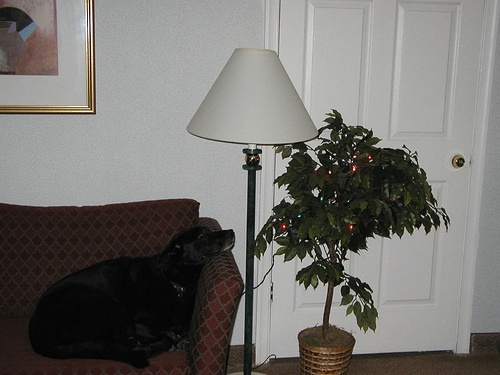Describe the objects in this image and their specific colors. I can see couch in maroon, black, darkgray, and gray tones, potted plant in maroon, black, darkgray, gray, and darkgreen tones, and dog in maroon, black, gray, and darkgray tones in this image. 